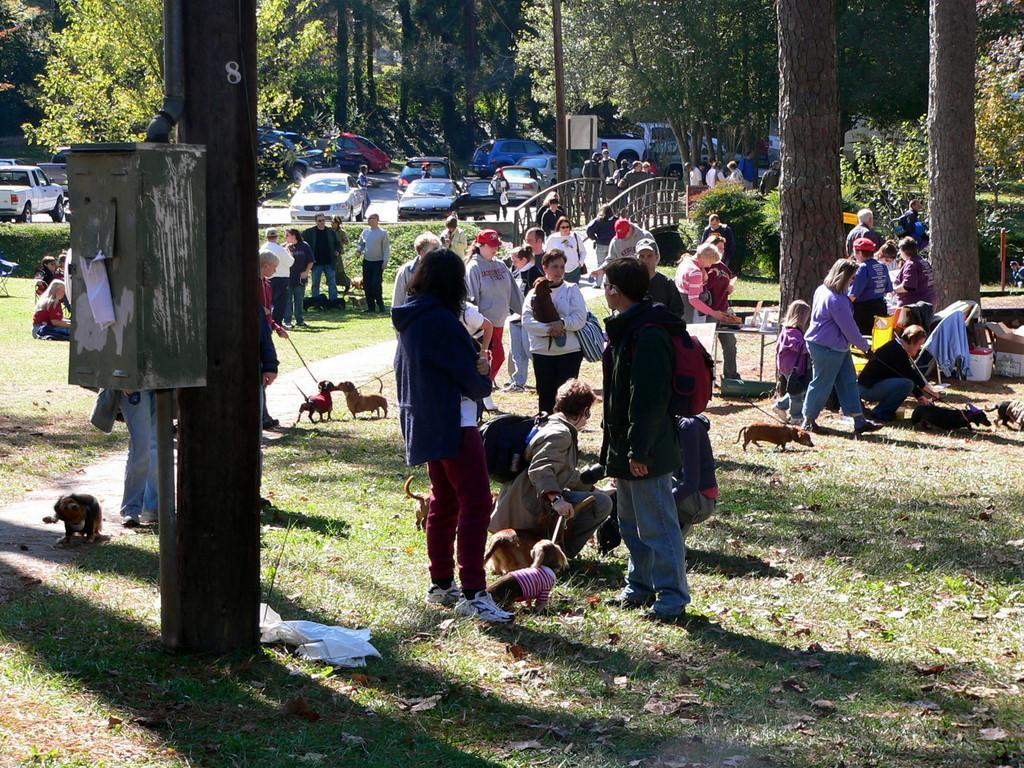In one or two sentences, can you explain what this image depicts? In this picture we can see a group of people,vehicles on the ground and in the background we can see trees. 